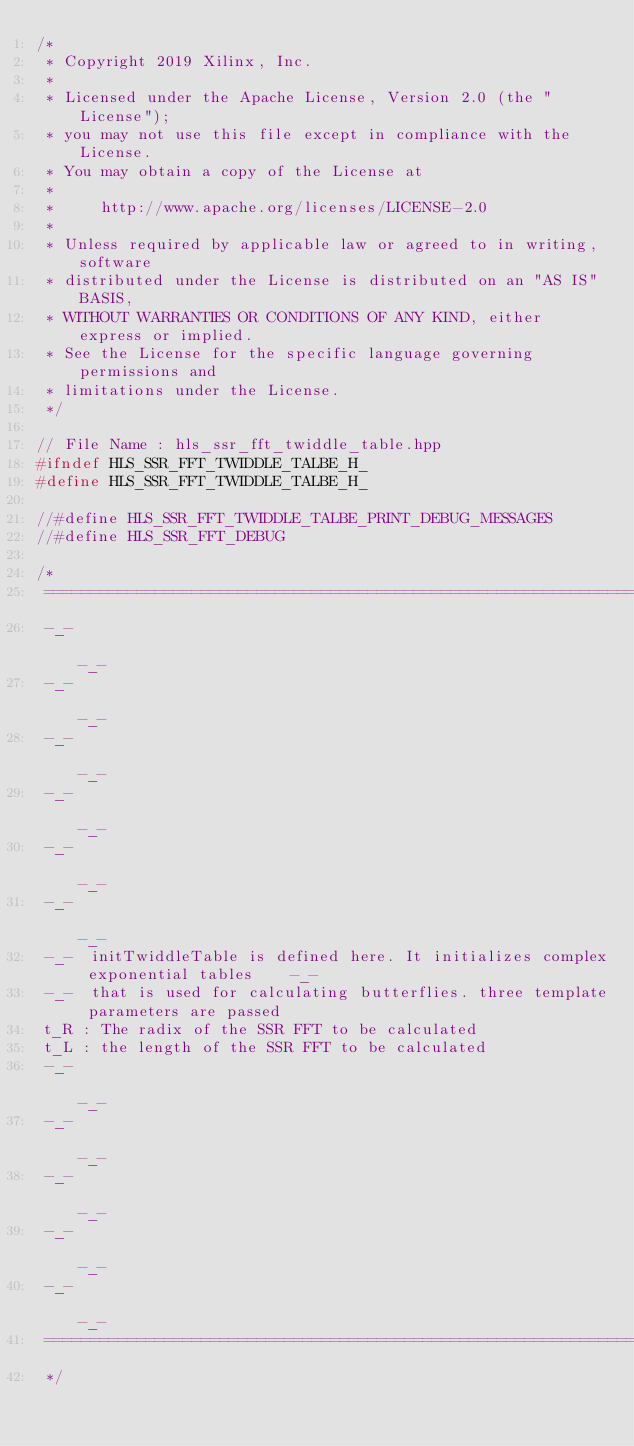Convert code to text. <code><loc_0><loc_0><loc_500><loc_500><_C++_>/*
 * Copyright 2019 Xilinx, Inc.
 *
 * Licensed under the Apache License, Version 2.0 (the "License");
 * you may not use this file except in compliance with the License.
 * You may obtain a copy of the License at
 *
 *     http://www.apache.org/licenses/LICENSE-2.0
 *
 * Unless required by applicable law or agreed to in writing, software
 * distributed under the License is distributed on an "AS IS" BASIS,
 * WITHOUT WARRANTIES OR CONDITIONS OF ANY KIND, either express or implied.
 * See the License for the specific language governing permissions and
 * limitations under the License.
 */

// File Name : hls_ssr_fft_twiddle_table.hpp
#ifndef HLS_SSR_FFT_TWIDDLE_TALBE_H_
#define HLS_SSR_FFT_TWIDDLE_TALBE_H_

//#define HLS_SSR_FFT_TWIDDLE_TALBE_PRINT_DEBUG_MESSAGES
//#define HLS_SSR_FFT_DEBUG

/*
 =========================================================================================
 -_-                                                                                   -_-
 -_-                                                                                   -_-
 -_-                                                                                   -_-
 -_-                                                                                   -_-
 -_-                                                                                   -_-
 -_-                                                                                   -_-
 -_-  initTwiddleTable is defined here. It initializes complex exponential tables    -_-
 -_-  that is used for calculating butterflies. three template parameters are passed
 t_R : The radix of the SSR FFT to be calculated
 t_L : the length of the SSR FFT to be calculated
 -_-                                                                                   -_-
 -_-                                                                                   -_-
 -_-                                                                                   -_-
 -_-                                                                                   -_-
 -_-                                                                                   -_-
 ========================================================================================
 */
</code> 